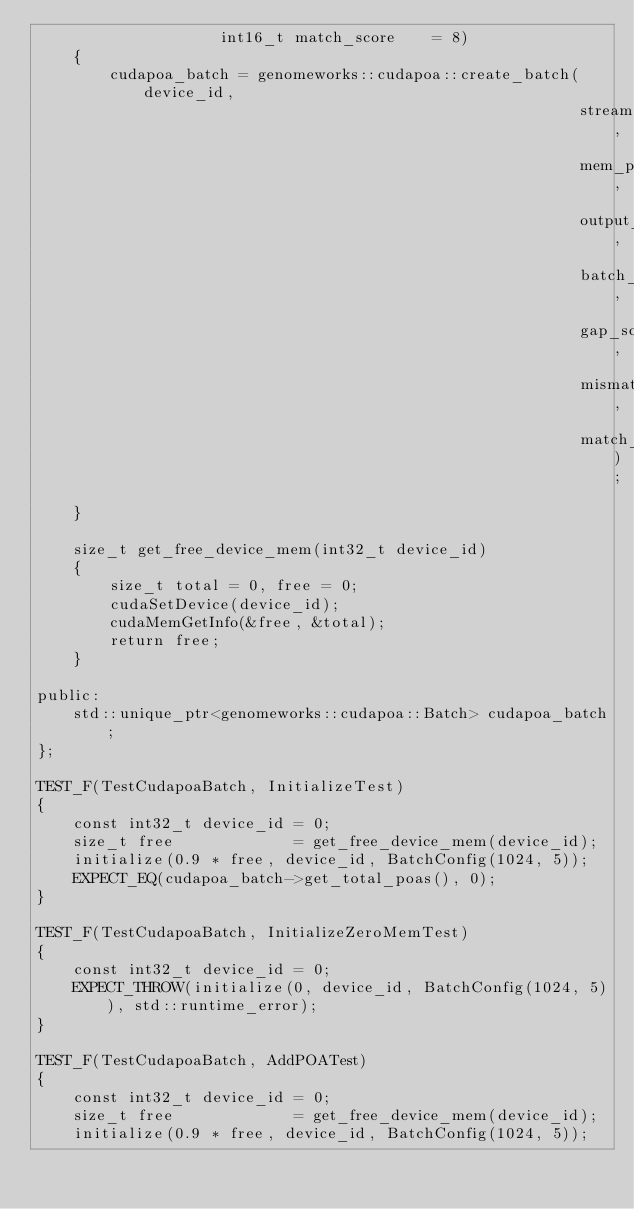<code> <loc_0><loc_0><loc_500><loc_500><_Cuda_>                    int16_t match_score    = 8)
    {
        cudapoa_batch = genomeworks::cudapoa::create_batch(device_id,
                                                           stream,
                                                           mem_per_batch,
                                                           output_mask,
                                                           batch_size,
                                                           gap_score,
                                                           mismatch_score,
                                                           match_score);
    }

    size_t get_free_device_mem(int32_t device_id)
    {
        size_t total = 0, free = 0;
        cudaSetDevice(device_id);
        cudaMemGetInfo(&free, &total);
        return free;
    }

public:
    std::unique_ptr<genomeworks::cudapoa::Batch> cudapoa_batch;
};

TEST_F(TestCudapoaBatch, InitializeTest)
{
    const int32_t device_id = 0;
    size_t free             = get_free_device_mem(device_id);
    initialize(0.9 * free, device_id, BatchConfig(1024, 5));
    EXPECT_EQ(cudapoa_batch->get_total_poas(), 0);
}

TEST_F(TestCudapoaBatch, InitializeZeroMemTest)
{
    const int32_t device_id = 0;
    EXPECT_THROW(initialize(0, device_id, BatchConfig(1024, 5)), std::runtime_error);
}

TEST_F(TestCudapoaBatch, AddPOATest)
{
    const int32_t device_id = 0;
    size_t free             = get_free_device_mem(device_id);
    initialize(0.9 * free, device_id, BatchConfig(1024, 5));</code> 